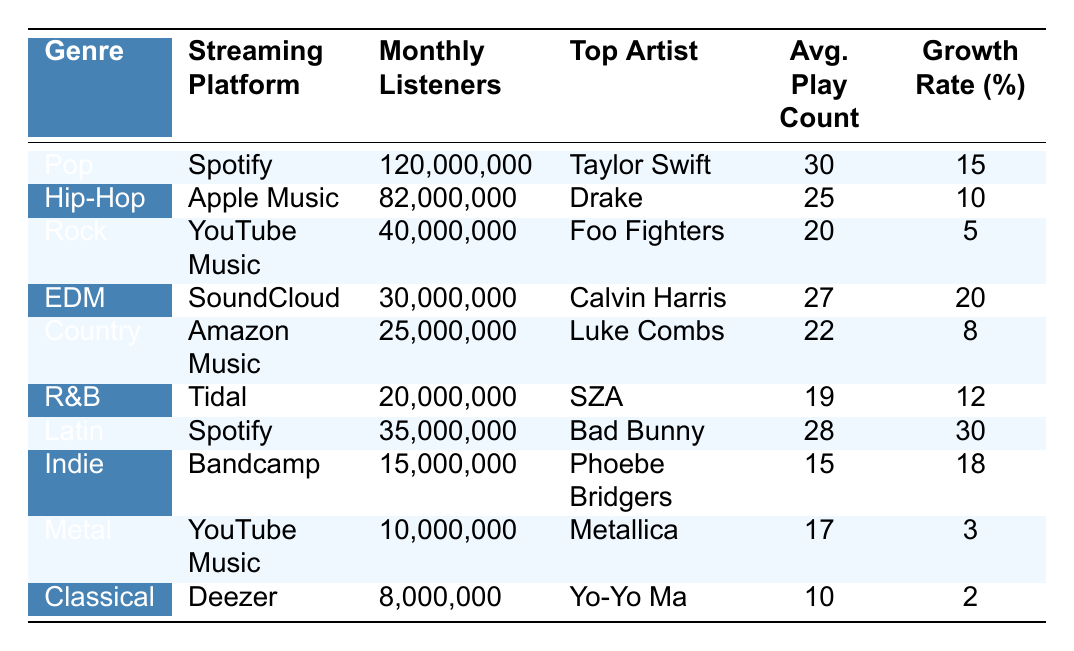What genre has the highest monthly listeners on Spotify? By looking at the table, we can see that the genre "Pop" has 120,000,000 monthly listeners on Spotify, which is the highest value in the data for a specific platform.
Answer: Pop Which streaming platform has the most monthly listeners for Hip-Hop? The table shows that "Hip-Hop" has 82,000,000 monthly listeners on "Apple Music," which is the only entry for Hip-Hop. Therefore, Apple's platform has the most listeners for this genre.
Answer: Apple Music What is the average play count for the top artist in Country? The table lists Luke Combs as the top artist in the Country genre with an average play count of 22. This is directly retrieved from the Country row in the table.
Answer: 22 How many total monthly listeners are there for Rock and Metal combined? By adding the monthly listeners for Rock and Metal, we get 40,000,000 (Rock) + 10,000,000 (Metal) = 50,000,000. This sum gives us the total combined monthly listeners for both genres.
Answer: 50000000 Which genre shows the highest growth rate percentage, and what is it? The table indicates that the genre "Latin" has a growth rate of 30%, which is the highest when compared to all other genres listed in the table. Therefore, Latin stands out as the highest.
Answer: Latin, 30% Is there more than one streaming platform that has monthly listeners for Indie? The table shows that "Indie" is listed under "Bandcamp" with 15,000,000 listeners, and there are no other entries for Indie in relation to different platforms. Therefore, no, there is only one.
Answer: No What is the difference between the average play counts for the top artists in Pop and R&B? The average play count for the top artist in Pop, Taylor Swift, is 30, while for R&B, SZA has an average of 19. The difference is calculated as 30 - 19 = 11.
Answer: 11 If we consider the genres listed, how many genres have a growth rate higher than 10%? The genres with a growth rate higher than 10% are Pop (15%), EDM (20%), Latin (30%), and Indie (18%). Counting these gives us a total of 4 genres.
Answer: 4 What is the average monthly listener count across all genres listed? To find the average, we sum all monthly listeners: 120,000,000 + 82,000,000 + 40,000,000 + 30,000,000 + 25,000,000 + 20,000,000 + 35,000,000 + 15,000,000 + 10,000,000 + 8,000,000 =  425,000,000 and divide by the number of genres (10): 425,000,000 / 10 = 42,500,000.
Answer: 42500000 Is the average play count for the top artist in Classical higher than that of Hip-Hop? The average play count for the top artist in Classical (10) is less than that of Hip-Hop (25). Therefore, this statement is false.
Answer: No 